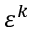<formula> <loc_0><loc_0><loc_500><loc_500>\varepsilon ^ { k }</formula> 